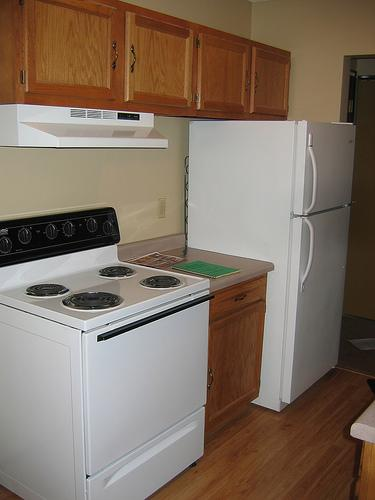What furniture and appliance color scheme is present in this kitchen? The kitchen has wooden cabinets, white appliances like the refrigerator, stove, and vent hood, and black trim on the stove. Analyze the arrangement of the depicted kitchen and comment on its organization. The kitchen is well-organized, with the white stove and white refrigerator placed near each other, and wooden cabinets above the counter. Objects are neatly placed on the counter. What type of kitchen cabinets are visible in this image and where are they placed in relation to the countertop? There are wooden cabinets in the kitchen, placed above the countertop. Name the objects placed on the counter visible in this image. A green notebook and a stack of advertisements or papers are placed on the counter. Evaluate the atmosphere of this kitchen and provide a sentiment associated with the image. The kitchen exudes a warm and inviting atmosphere, with the wooden cabinets and well-organized layout evoking a feeling of coziness and comfort. What do you think the purpose of the green book on the counter might be in this context? The green book could be a cookbook, a notebook for grocery lists, or a planner to manage household tasks. Describe the type of flooring in the kitchen based on the image provided. The kitchen has a wooden plank floor, which appears to be hardwood. Describe the position and purpose of the white vent in the kitchen. The white vent is located above the stove, serving as an overhead ventilation system to remove smoke, steam, and cooking smells. Count the number of burners visible on the stove and describe their color. There are four black electric burners on the stove top. Provide a brief description of the overall scene captured in the image. A kitchen featuring wooden cabinets, a white stove with black burners, a white refrigerator, and various objects like a green notebook and papers on a counter. 